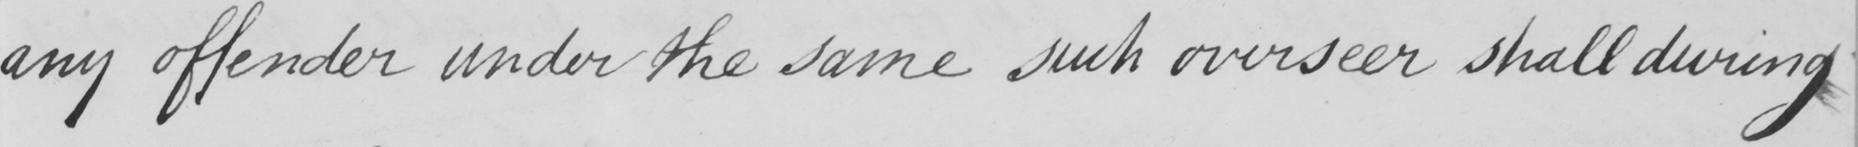What does this handwritten line say? any offender under the same such overseer shall during 